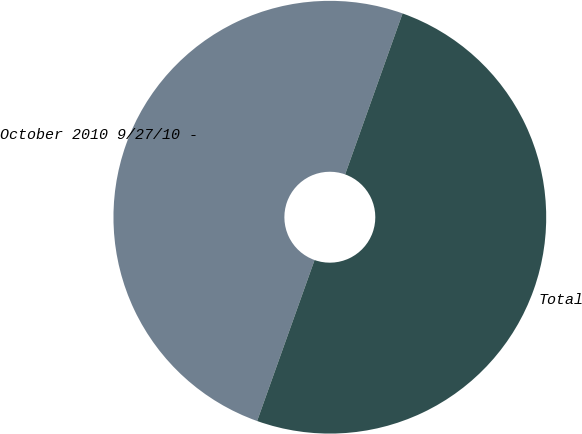Convert chart to OTSL. <chart><loc_0><loc_0><loc_500><loc_500><pie_chart><fcel>October 2010 9/27/10 -<fcel>Total<nl><fcel>50.0%<fcel>50.0%<nl></chart> 